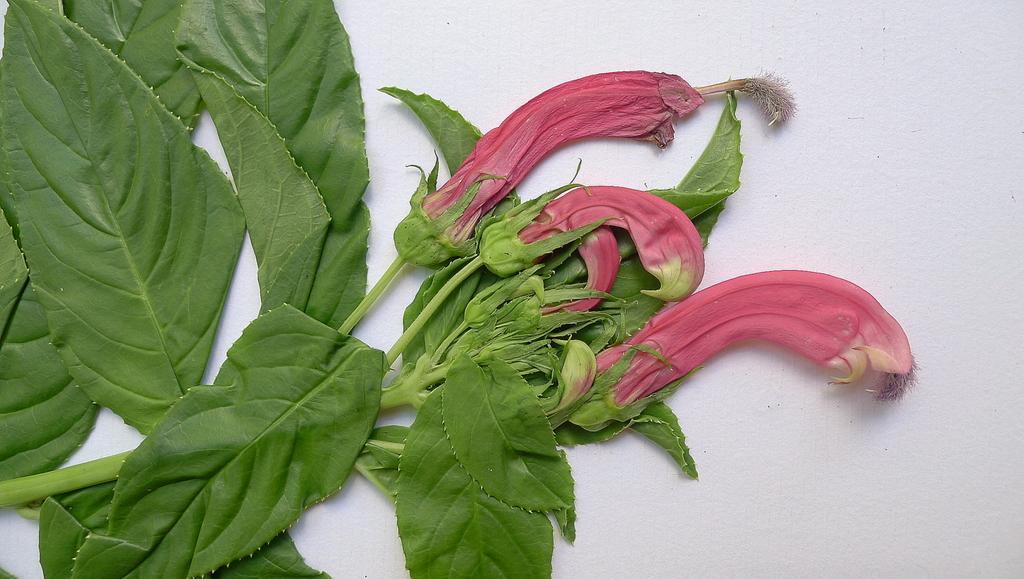How would you summarize this image in a sentence or two? In this picture we can see a plant with flowers and the plant is on the white surface. 